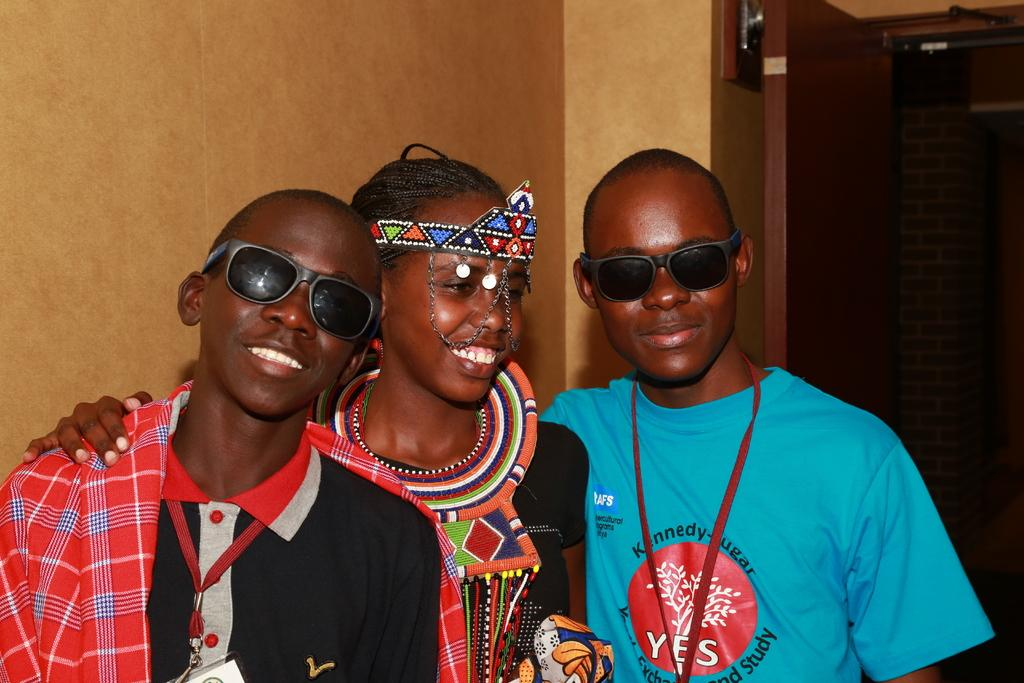How many people are in the image? There are three persons in the image. What are the persons wearing? The persons are wearing clothes. Where are the persons located in the image? The persons are in front of a wall. What can be seen on the right side of the image? There is a door on the right side of the image. What type of cave can be seen in the background of the image? There is no cave present in the image; it features three persons in front of a wall with a door on the right side. What type of jail is depicted in the image? There is no jail depicted in the image; it features three persons in front of a wall with a door on the right side. 